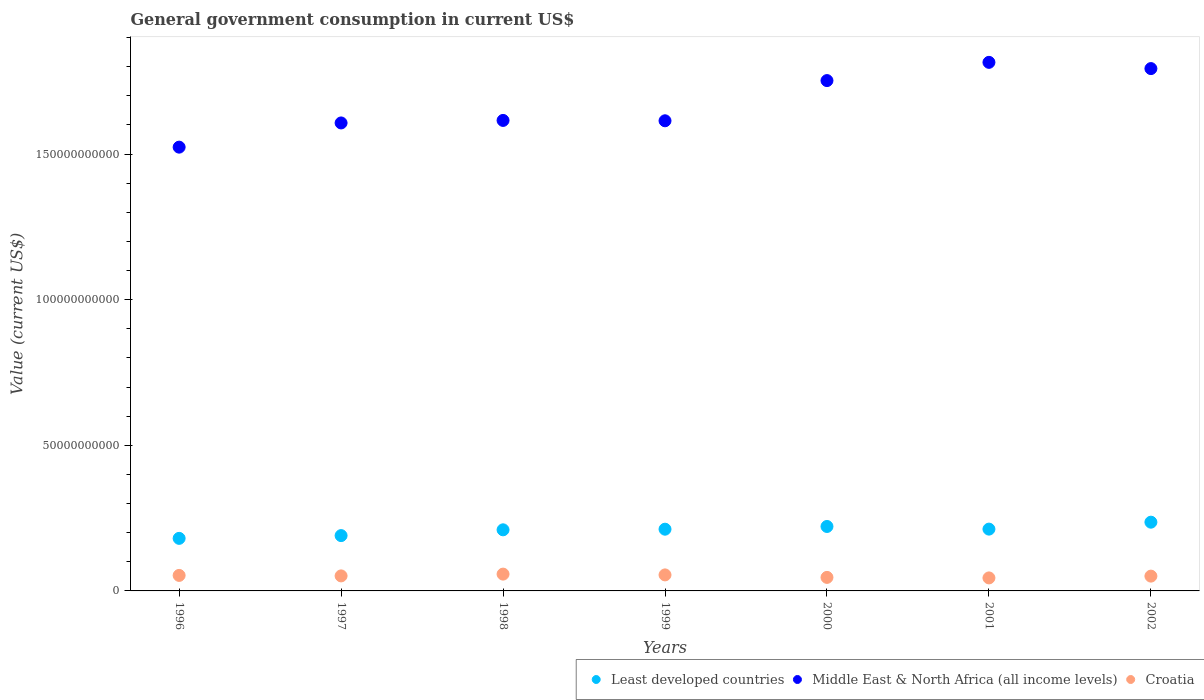How many different coloured dotlines are there?
Provide a short and direct response. 3. What is the government conusmption in Middle East & North Africa (all income levels) in 1998?
Your answer should be very brief. 1.62e+11. Across all years, what is the maximum government conusmption in Croatia?
Offer a very short reply. 5.77e+09. Across all years, what is the minimum government conusmption in Middle East & North Africa (all income levels)?
Keep it short and to the point. 1.52e+11. In which year was the government conusmption in Middle East & North Africa (all income levels) maximum?
Your response must be concise. 2001. In which year was the government conusmption in Least developed countries minimum?
Your answer should be compact. 1996. What is the total government conusmption in Middle East & North Africa (all income levels) in the graph?
Keep it short and to the point. 1.17e+12. What is the difference between the government conusmption in Croatia in 1999 and that in 2000?
Your answer should be compact. 8.54e+08. What is the difference between the government conusmption in Croatia in 1998 and the government conusmption in Middle East & North Africa (all income levels) in 1999?
Your answer should be very brief. -1.56e+11. What is the average government conusmption in Middle East & North Africa (all income levels) per year?
Offer a terse response. 1.67e+11. In the year 2000, what is the difference between the government conusmption in Croatia and government conusmption in Least developed countries?
Offer a terse response. -1.75e+1. What is the ratio of the government conusmption in Croatia in 1996 to that in 2001?
Give a very brief answer. 1.19. Is the government conusmption in Middle East & North Africa (all income levels) in 1998 less than that in 2000?
Offer a terse response. Yes. Is the difference between the government conusmption in Croatia in 1997 and 1998 greater than the difference between the government conusmption in Least developed countries in 1997 and 1998?
Keep it short and to the point. Yes. What is the difference between the highest and the second highest government conusmption in Croatia?
Your response must be concise. 2.72e+08. What is the difference between the highest and the lowest government conusmption in Least developed countries?
Provide a short and direct response. 5.56e+09. Is the sum of the government conusmption in Least developed countries in 1996 and 1997 greater than the maximum government conusmption in Croatia across all years?
Offer a terse response. Yes. Is the government conusmption in Middle East & North Africa (all income levels) strictly greater than the government conusmption in Least developed countries over the years?
Keep it short and to the point. Yes. How many dotlines are there?
Give a very brief answer. 3. Does the graph contain grids?
Keep it short and to the point. No. Where does the legend appear in the graph?
Your answer should be compact. Bottom right. How are the legend labels stacked?
Keep it short and to the point. Horizontal. What is the title of the graph?
Your answer should be compact. General government consumption in current US$. Does "Argentina" appear as one of the legend labels in the graph?
Your answer should be very brief. No. What is the label or title of the Y-axis?
Give a very brief answer. Value (current US$). What is the Value (current US$) of Least developed countries in 1996?
Provide a succinct answer. 1.80e+1. What is the Value (current US$) in Middle East & North Africa (all income levels) in 1996?
Keep it short and to the point. 1.52e+11. What is the Value (current US$) of Croatia in 1996?
Ensure brevity in your answer.  5.33e+09. What is the Value (current US$) of Least developed countries in 1997?
Make the answer very short. 1.90e+1. What is the Value (current US$) of Middle East & North Africa (all income levels) in 1997?
Ensure brevity in your answer.  1.61e+11. What is the Value (current US$) in Croatia in 1997?
Your answer should be compact. 5.16e+09. What is the Value (current US$) of Least developed countries in 1998?
Offer a terse response. 2.10e+1. What is the Value (current US$) of Middle East & North Africa (all income levels) in 1998?
Give a very brief answer. 1.62e+11. What is the Value (current US$) in Croatia in 1998?
Give a very brief answer. 5.77e+09. What is the Value (current US$) in Least developed countries in 1999?
Offer a very short reply. 2.12e+1. What is the Value (current US$) in Middle East & North Africa (all income levels) in 1999?
Make the answer very short. 1.61e+11. What is the Value (current US$) in Croatia in 1999?
Give a very brief answer. 5.50e+09. What is the Value (current US$) of Least developed countries in 2000?
Provide a succinct answer. 2.21e+1. What is the Value (current US$) in Middle East & North Africa (all income levels) in 2000?
Make the answer very short. 1.75e+11. What is the Value (current US$) in Croatia in 2000?
Offer a terse response. 4.65e+09. What is the Value (current US$) in Least developed countries in 2001?
Provide a short and direct response. 2.12e+1. What is the Value (current US$) of Middle East & North Africa (all income levels) in 2001?
Provide a short and direct response. 1.81e+11. What is the Value (current US$) of Croatia in 2001?
Make the answer very short. 4.47e+09. What is the Value (current US$) of Least developed countries in 2002?
Offer a terse response. 2.36e+1. What is the Value (current US$) of Middle East & North Africa (all income levels) in 2002?
Give a very brief answer. 1.79e+11. What is the Value (current US$) in Croatia in 2002?
Give a very brief answer. 5.08e+09. Across all years, what is the maximum Value (current US$) in Least developed countries?
Provide a short and direct response. 2.36e+1. Across all years, what is the maximum Value (current US$) of Middle East & North Africa (all income levels)?
Your answer should be compact. 1.81e+11. Across all years, what is the maximum Value (current US$) of Croatia?
Provide a succinct answer. 5.77e+09. Across all years, what is the minimum Value (current US$) in Least developed countries?
Provide a short and direct response. 1.80e+1. Across all years, what is the minimum Value (current US$) in Middle East & North Africa (all income levels)?
Provide a succinct answer. 1.52e+11. Across all years, what is the minimum Value (current US$) in Croatia?
Give a very brief answer. 4.47e+09. What is the total Value (current US$) of Least developed countries in the graph?
Your answer should be very brief. 1.46e+11. What is the total Value (current US$) in Middle East & North Africa (all income levels) in the graph?
Your answer should be very brief. 1.17e+12. What is the total Value (current US$) in Croatia in the graph?
Keep it short and to the point. 3.59e+1. What is the difference between the Value (current US$) of Least developed countries in 1996 and that in 1997?
Make the answer very short. -9.50e+08. What is the difference between the Value (current US$) of Middle East & North Africa (all income levels) in 1996 and that in 1997?
Your answer should be very brief. -8.31e+09. What is the difference between the Value (current US$) of Croatia in 1996 and that in 1997?
Give a very brief answer. 1.67e+08. What is the difference between the Value (current US$) of Least developed countries in 1996 and that in 1998?
Offer a terse response. -2.93e+09. What is the difference between the Value (current US$) in Middle East & North Africa (all income levels) in 1996 and that in 1998?
Your answer should be very brief. -9.18e+09. What is the difference between the Value (current US$) in Croatia in 1996 and that in 1998?
Your response must be concise. -4.45e+08. What is the difference between the Value (current US$) in Least developed countries in 1996 and that in 1999?
Your answer should be compact. -3.15e+09. What is the difference between the Value (current US$) in Middle East & North Africa (all income levels) in 1996 and that in 1999?
Offer a terse response. -9.05e+09. What is the difference between the Value (current US$) in Croatia in 1996 and that in 1999?
Make the answer very short. -1.73e+08. What is the difference between the Value (current US$) in Least developed countries in 1996 and that in 2000?
Provide a short and direct response. -4.08e+09. What is the difference between the Value (current US$) of Middle East & North Africa (all income levels) in 1996 and that in 2000?
Offer a terse response. -2.29e+1. What is the difference between the Value (current US$) in Croatia in 1996 and that in 2000?
Ensure brevity in your answer.  6.81e+08. What is the difference between the Value (current US$) of Least developed countries in 1996 and that in 2001?
Make the answer very short. -3.17e+09. What is the difference between the Value (current US$) of Middle East & North Africa (all income levels) in 1996 and that in 2001?
Give a very brief answer. -2.91e+1. What is the difference between the Value (current US$) of Croatia in 1996 and that in 2001?
Offer a terse response. 8.59e+08. What is the difference between the Value (current US$) of Least developed countries in 1996 and that in 2002?
Keep it short and to the point. -5.56e+09. What is the difference between the Value (current US$) in Middle East & North Africa (all income levels) in 1996 and that in 2002?
Offer a terse response. -2.70e+1. What is the difference between the Value (current US$) of Croatia in 1996 and that in 2002?
Make the answer very short. 2.45e+08. What is the difference between the Value (current US$) of Least developed countries in 1997 and that in 1998?
Provide a short and direct response. -1.98e+09. What is the difference between the Value (current US$) in Middle East & North Africa (all income levels) in 1997 and that in 1998?
Give a very brief answer. -8.66e+08. What is the difference between the Value (current US$) of Croatia in 1997 and that in 1998?
Give a very brief answer. -6.12e+08. What is the difference between the Value (current US$) of Least developed countries in 1997 and that in 1999?
Make the answer very short. -2.20e+09. What is the difference between the Value (current US$) in Middle East & North Africa (all income levels) in 1997 and that in 1999?
Your answer should be very brief. -7.43e+08. What is the difference between the Value (current US$) in Croatia in 1997 and that in 1999?
Offer a very short reply. -3.41e+08. What is the difference between the Value (current US$) of Least developed countries in 1997 and that in 2000?
Offer a terse response. -3.13e+09. What is the difference between the Value (current US$) in Middle East & North Africa (all income levels) in 1997 and that in 2000?
Ensure brevity in your answer.  -1.45e+1. What is the difference between the Value (current US$) of Croatia in 1997 and that in 2000?
Keep it short and to the point. 5.13e+08. What is the difference between the Value (current US$) of Least developed countries in 1997 and that in 2001?
Offer a terse response. -2.22e+09. What is the difference between the Value (current US$) in Middle East & North Africa (all income levels) in 1997 and that in 2001?
Ensure brevity in your answer.  -2.08e+1. What is the difference between the Value (current US$) in Croatia in 1997 and that in 2001?
Ensure brevity in your answer.  6.92e+08. What is the difference between the Value (current US$) of Least developed countries in 1997 and that in 2002?
Offer a very short reply. -4.61e+09. What is the difference between the Value (current US$) in Middle East & North Africa (all income levels) in 1997 and that in 2002?
Your answer should be very brief. -1.87e+1. What is the difference between the Value (current US$) of Croatia in 1997 and that in 2002?
Give a very brief answer. 7.82e+07. What is the difference between the Value (current US$) of Least developed countries in 1998 and that in 1999?
Make the answer very short. -2.15e+08. What is the difference between the Value (current US$) in Middle East & North Africa (all income levels) in 1998 and that in 1999?
Offer a very short reply. 1.24e+08. What is the difference between the Value (current US$) of Croatia in 1998 and that in 1999?
Your response must be concise. 2.72e+08. What is the difference between the Value (current US$) in Least developed countries in 1998 and that in 2000?
Keep it short and to the point. -1.15e+09. What is the difference between the Value (current US$) in Middle East & North Africa (all income levels) in 1998 and that in 2000?
Offer a terse response. -1.37e+1. What is the difference between the Value (current US$) in Croatia in 1998 and that in 2000?
Ensure brevity in your answer.  1.13e+09. What is the difference between the Value (current US$) of Least developed countries in 1998 and that in 2001?
Make the answer very short. -2.39e+08. What is the difference between the Value (current US$) of Middle East & North Africa (all income levels) in 1998 and that in 2001?
Your answer should be very brief. -1.99e+1. What is the difference between the Value (current US$) of Croatia in 1998 and that in 2001?
Give a very brief answer. 1.30e+09. What is the difference between the Value (current US$) of Least developed countries in 1998 and that in 2002?
Offer a terse response. -2.62e+09. What is the difference between the Value (current US$) in Middle East & North Africa (all income levels) in 1998 and that in 2002?
Your answer should be very brief. -1.78e+1. What is the difference between the Value (current US$) in Croatia in 1998 and that in 2002?
Give a very brief answer. 6.91e+08. What is the difference between the Value (current US$) of Least developed countries in 1999 and that in 2000?
Ensure brevity in your answer.  -9.33e+08. What is the difference between the Value (current US$) of Middle East & North Africa (all income levels) in 1999 and that in 2000?
Provide a short and direct response. -1.38e+1. What is the difference between the Value (current US$) of Croatia in 1999 and that in 2000?
Give a very brief answer. 8.54e+08. What is the difference between the Value (current US$) of Least developed countries in 1999 and that in 2001?
Provide a succinct answer. -2.41e+07. What is the difference between the Value (current US$) of Middle East & North Africa (all income levels) in 1999 and that in 2001?
Provide a succinct answer. -2.01e+1. What is the difference between the Value (current US$) in Croatia in 1999 and that in 2001?
Give a very brief answer. 1.03e+09. What is the difference between the Value (current US$) in Least developed countries in 1999 and that in 2002?
Provide a succinct answer. -2.41e+09. What is the difference between the Value (current US$) in Middle East & North Africa (all income levels) in 1999 and that in 2002?
Your response must be concise. -1.79e+1. What is the difference between the Value (current US$) of Croatia in 1999 and that in 2002?
Your answer should be very brief. 4.19e+08. What is the difference between the Value (current US$) in Least developed countries in 2000 and that in 2001?
Your answer should be very brief. 9.09e+08. What is the difference between the Value (current US$) in Middle East & North Africa (all income levels) in 2000 and that in 2001?
Keep it short and to the point. -6.26e+09. What is the difference between the Value (current US$) of Croatia in 2000 and that in 2001?
Give a very brief answer. 1.78e+08. What is the difference between the Value (current US$) in Least developed countries in 2000 and that in 2002?
Offer a terse response. -1.47e+09. What is the difference between the Value (current US$) in Middle East & North Africa (all income levels) in 2000 and that in 2002?
Provide a short and direct response. -4.12e+09. What is the difference between the Value (current US$) of Croatia in 2000 and that in 2002?
Keep it short and to the point. -4.35e+08. What is the difference between the Value (current US$) of Least developed countries in 2001 and that in 2002?
Provide a short and direct response. -2.38e+09. What is the difference between the Value (current US$) of Middle East & North Africa (all income levels) in 2001 and that in 2002?
Give a very brief answer. 2.14e+09. What is the difference between the Value (current US$) of Croatia in 2001 and that in 2002?
Ensure brevity in your answer.  -6.14e+08. What is the difference between the Value (current US$) of Least developed countries in 1996 and the Value (current US$) of Middle East & North Africa (all income levels) in 1997?
Your response must be concise. -1.43e+11. What is the difference between the Value (current US$) in Least developed countries in 1996 and the Value (current US$) in Croatia in 1997?
Your answer should be compact. 1.29e+1. What is the difference between the Value (current US$) of Middle East & North Africa (all income levels) in 1996 and the Value (current US$) of Croatia in 1997?
Your response must be concise. 1.47e+11. What is the difference between the Value (current US$) of Least developed countries in 1996 and the Value (current US$) of Middle East & North Africa (all income levels) in 1998?
Provide a short and direct response. -1.44e+11. What is the difference between the Value (current US$) of Least developed countries in 1996 and the Value (current US$) of Croatia in 1998?
Your answer should be compact. 1.23e+1. What is the difference between the Value (current US$) in Middle East & North Africa (all income levels) in 1996 and the Value (current US$) in Croatia in 1998?
Offer a terse response. 1.47e+11. What is the difference between the Value (current US$) in Least developed countries in 1996 and the Value (current US$) in Middle East & North Africa (all income levels) in 1999?
Your response must be concise. -1.43e+11. What is the difference between the Value (current US$) of Least developed countries in 1996 and the Value (current US$) of Croatia in 1999?
Offer a terse response. 1.25e+1. What is the difference between the Value (current US$) in Middle East & North Africa (all income levels) in 1996 and the Value (current US$) in Croatia in 1999?
Give a very brief answer. 1.47e+11. What is the difference between the Value (current US$) in Least developed countries in 1996 and the Value (current US$) in Middle East & North Africa (all income levels) in 2000?
Your response must be concise. -1.57e+11. What is the difference between the Value (current US$) in Least developed countries in 1996 and the Value (current US$) in Croatia in 2000?
Give a very brief answer. 1.34e+1. What is the difference between the Value (current US$) in Middle East & North Africa (all income levels) in 1996 and the Value (current US$) in Croatia in 2000?
Your answer should be compact. 1.48e+11. What is the difference between the Value (current US$) in Least developed countries in 1996 and the Value (current US$) in Middle East & North Africa (all income levels) in 2001?
Keep it short and to the point. -1.63e+11. What is the difference between the Value (current US$) in Least developed countries in 1996 and the Value (current US$) in Croatia in 2001?
Provide a short and direct response. 1.36e+1. What is the difference between the Value (current US$) of Middle East & North Africa (all income levels) in 1996 and the Value (current US$) of Croatia in 2001?
Provide a short and direct response. 1.48e+11. What is the difference between the Value (current US$) of Least developed countries in 1996 and the Value (current US$) of Middle East & North Africa (all income levels) in 2002?
Offer a very short reply. -1.61e+11. What is the difference between the Value (current US$) of Least developed countries in 1996 and the Value (current US$) of Croatia in 2002?
Ensure brevity in your answer.  1.30e+1. What is the difference between the Value (current US$) in Middle East & North Africa (all income levels) in 1996 and the Value (current US$) in Croatia in 2002?
Keep it short and to the point. 1.47e+11. What is the difference between the Value (current US$) in Least developed countries in 1997 and the Value (current US$) in Middle East & North Africa (all income levels) in 1998?
Ensure brevity in your answer.  -1.43e+11. What is the difference between the Value (current US$) in Least developed countries in 1997 and the Value (current US$) in Croatia in 1998?
Offer a very short reply. 1.32e+1. What is the difference between the Value (current US$) of Middle East & North Africa (all income levels) in 1997 and the Value (current US$) of Croatia in 1998?
Provide a succinct answer. 1.55e+11. What is the difference between the Value (current US$) of Least developed countries in 1997 and the Value (current US$) of Middle East & North Africa (all income levels) in 1999?
Provide a short and direct response. -1.42e+11. What is the difference between the Value (current US$) in Least developed countries in 1997 and the Value (current US$) in Croatia in 1999?
Your answer should be compact. 1.35e+1. What is the difference between the Value (current US$) of Middle East & North Africa (all income levels) in 1997 and the Value (current US$) of Croatia in 1999?
Your response must be concise. 1.55e+11. What is the difference between the Value (current US$) in Least developed countries in 1997 and the Value (current US$) in Middle East & North Africa (all income levels) in 2000?
Your answer should be very brief. -1.56e+11. What is the difference between the Value (current US$) of Least developed countries in 1997 and the Value (current US$) of Croatia in 2000?
Your answer should be compact. 1.44e+1. What is the difference between the Value (current US$) in Middle East & North Africa (all income levels) in 1997 and the Value (current US$) in Croatia in 2000?
Offer a very short reply. 1.56e+11. What is the difference between the Value (current US$) of Least developed countries in 1997 and the Value (current US$) of Middle East & North Africa (all income levels) in 2001?
Make the answer very short. -1.63e+11. What is the difference between the Value (current US$) of Least developed countries in 1997 and the Value (current US$) of Croatia in 2001?
Give a very brief answer. 1.45e+1. What is the difference between the Value (current US$) of Middle East & North Africa (all income levels) in 1997 and the Value (current US$) of Croatia in 2001?
Keep it short and to the point. 1.56e+11. What is the difference between the Value (current US$) of Least developed countries in 1997 and the Value (current US$) of Middle East & North Africa (all income levels) in 2002?
Your answer should be compact. -1.60e+11. What is the difference between the Value (current US$) of Least developed countries in 1997 and the Value (current US$) of Croatia in 2002?
Keep it short and to the point. 1.39e+1. What is the difference between the Value (current US$) of Middle East & North Africa (all income levels) in 1997 and the Value (current US$) of Croatia in 2002?
Your answer should be compact. 1.56e+11. What is the difference between the Value (current US$) of Least developed countries in 1998 and the Value (current US$) of Middle East & North Africa (all income levels) in 1999?
Give a very brief answer. -1.40e+11. What is the difference between the Value (current US$) of Least developed countries in 1998 and the Value (current US$) of Croatia in 1999?
Offer a very short reply. 1.55e+1. What is the difference between the Value (current US$) in Middle East & North Africa (all income levels) in 1998 and the Value (current US$) in Croatia in 1999?
Your answer should be compact. 1.56e+11. What is the difference between the Value (current US$) in Least developed countries in 1998 and the Value (current US$) in Middle East & North Africa (all income levels) in 2000?
Make the answer very short. -1.54e+11. What is the difference between the Value (current US$) in Least developed countries in 1998 and the Value (current US$) in Croatia in 2000?
Make the answer very short. 1.63e+1. What is the difference between the Value (current US$) in Middle East & North Africa (all income levels) in 1998 and the Value (current US$) in Croatia in 2000?
Your answer should be compact. 1.57e+11. What is the difference between the Value (current US$) of Least developed countries in 1998 and the Value (current US$) of Middle East & North Africa (all income levels) in 2001?
Make the answer very short. -1.61e+11. What is the difference between the Value (current US$) in Least developed countries in 1998 and the Value (current US$) in Croatia in 2001?
Give a very brief answer. 1.65e+1. What is the difference between the Value (current US$) in Middle East & North Africa (all income levels) in 1998 and the Value (current US$) in Croatia in 2001?
Your response must be concise. 1.57e+11. What is the difference between the Value (current US$) in Least developed countries in 1998 and the Value (current US$) in Middle East & North Africa (all income levels) in 2002?
Offer a terse response. -1.58e+11. What is the difference between the Value (current US$) in Least developed countries in 1998 and the Value (current US$) in Croatia in 2002?
Provide a short and direct response. 1.59e+1. What is the difference between the Value (current US$) of Middle East & North Africa (all income levels) in 1998 and the Value (current US$) of Croatia in 2002?
Give a very brief answer. 1.56e+11. What is the difference between the Value (current US$) of Least developed countries in 1999 and the Value (current US$) of Middle East & North Africa (all income levels) in 2000?
Your answer should be very brief. -1.54e+11. What is the difference between the Value (current US$) of Least developed countries in 1999 and the Value (current US$) of Croatia in 2000?
Provide a succinct answer. 1.66e+1. What is the difference between the Value (current US$) in Middle East & North Africa (all income levels) in 1999 and the Value (current US$) in Croatia in 2000?
Provide a succinct answer. 1.57e+11. What is the difference between the Value (current US$) in Least developed countries in 1999 and the Value (current US$) in Middle East & North Africa (all income levels) in 2001?
Provide a succinct answer. -1.60e+11. What is the difference between the Value (current US$) of Least developed countries in 1999 and the Value (current US$) of Croatia in 2001?
Offer a very short reply. 1.67e+1. What is the difference between the Value (current US$) in Middle East & North Africa (all income levels) in 1999 and the Value (current US$) in Croatia in 2001?
Keep it short and to the point. 1.57e+11. What is the difference between the Value (current US$) of Least developed countries in 1999 and the Value (current US$) of Middle East & North Africa (all income levels) in 2002?
Your answer should be very brief. -1.58e+11. What is the difference between the Value (current US$) in Least developed countries in 1999 and the Value (current US$) in Croatia in 2002?
Offer a very short reply. 1.61e+1. What is the difference between the Value (current US$) of Middle East & North Africa (all income levels) in 1999 and the Value (current US$) of Croatia in 2002?
Your answer should be compact. 1.56e+11. What is the difference between the Value (current US$) in Least developed countries in 2000 and the Value (current US$) in Middle East & North Africa (all income levels) in 2001?
Keep it short and to the point. -1.59e+11. What is the difference between the Value (current US$) of Least developed countries in 2000 and the Value (current US$) of Croatia in 2001?
Provide a short and direct response. 1.77e+1. What is the difference between the Value (current US$) in Middle East & North Africa (all income levels) in 2000 and the Value (current US$) in Croatia in 2001?
Keep it short and to the point. 1.71e+11. What is the difference between the Value (current US$) of Least developed countries in 2000 and the Value (current US$) of Middle East & North Africa (all income levels) in 2002?
Your answer should be compact. -1.57e+11. What is the difference between the Value (current US$) in Least developed countries in 2000 and the Value (current US$) in Croatia in 2002?
Offer a terse response. 1.70e+1. What is the difference between the Value (current US$) in Middle East & North Africa (all income levels) in 2000 and the Value (current US$) in Croatia in 2002?
Ensure brevity in your answer.  1.70e+11. What is the difference between the Value (current US$) of Least developed countries in 2001 and the Value (current US$) of Middle East & North Africa (all income levels) in 2002?
Offer a terse response. -1.58e+11. What is the difference between the Value (current US$) of Least developed countries in 2001 and the Value (current US$) of Croatia in 2002?
Offer a terse response. 1.61e+1. What is the difference between the Value (current US$) in Middle East & North Africa (all income levels) in 2001 and the Value (current US$) in Croatia in 2002?
Make the answer very short. 1.76e+11. What is the average Value (current US$) in Least developed countries per year?
Offer a terse response. 2.09e+1. What is the average Value (current US$) of Middle East & North Africa (all income levels) per year?
Your answer should be compact. 1.67e+11. What is the average Value (current US$) in Croatia per year?
Your answer should be compact. 5.14e+09. In the year 1996, what is the difference between the Value (current US$) of Least developed countries and Value (current US$) of Middle East & North Africa (all income levels)?
Make the answer very short. -1.34e+11. In the year 1996, what is the difference between the Value (current US$) in Least developed countries and Value (current US$) in Croatia?
Ensure brevity in your answer.  1.27e+1. In the year 1996, what is the difference between the Value (current US$) in Middle East & North Africa (all income levels) and Value (current US$) in Croatia?
Your answer should be very brief. 1.47e+11. In the year 1997, what is the difference between the Value (current US$) of Least developed countries and Value (current US$) of Middle East & North Africa (all income levels)?
Your answer should be very brief. -1.42e+11. In the year 1997, what is the difference between the Value (current US$) in Least developed countries and Value (current US$) in Croatia?
Give a very brief answer. 1.38e+1. In the year 1997, what is the difference between the Value (current US$) in Middle East & North Africa (all income levels) and Value (current US$) in Croatia?
Keep it short and to the point. 1.56e+11. In the year 1998, what is the difference between the Value (current US$) in Least developed countries and Value (current US$) in Middle East & North Africa (all income levels)?
Offer a very short reply. -1.41e+11. In the year 1998, what is the difference between the Value (current US$) of Least developed countries and Value (current US$) of Croatia?
Your response must be concise. 1.52e+1. In the year 1998, what is the difference between the Value (current US$) in Middle East & North Africa (all income levels) and Value (current US$) in Croatia?
Provide a short and direct response. 1.56e+11. In the year 1999, what is the difference between the Value (current US$) in Least developed countries and Value (current US$) in Middle East & North Africa (all income levels)?
Your answer should be compact. -1.40e+11. In the year 1999, what is the difference between the Value (current US$) of Least developed countries and Value (current US$) of Croatia?
Offer a terse response. 1.57e+1. In the year 1999, what is the difference between the Value (current US$) of Middle East & North Africa (all income levels) and Value (current US$) of Croatia?
Your answer should be very brief. 1.56e+11. In the year 2000, what is the difference between the Value (current US$) of Least developed countries and Value (current US$) of Middle East & North Africa (all income levels)?
Make the answer very short. -1.53e+11. In the year 2000, what is the difference between the Value (current US$) in Least developed countries and Value (current US$) in Croatia?
Your answer should be compact. 1.75e+1. In the year 2000, what is the difference between the Value (current US$) in Middle East & North Africa (all income levels) and Value (current US$) in Croatia?
Offer a terse response. 1.71e+11. In the year 2001, what is the difference between the Value (current US$) of Least developed countries and Value (current US$) of Middle East & North Africa (all income levels)?
Offer a terse response. -1.60e+11. In the year 2001, what is the difference between the Value (current US$) of Least developed countries and Value (current US$) of Croatia?
Ensure brevity in your answer.  1.68e+1. In the year 2001, what is the difference between the Value (current US$) of Middle East & North Africa (all income levels) and Value (current US$) of Croatia?
Keep it short and to the point. 1.77e+11. In the year 2002, what is the difference between the Value (current US$) of Least developed countries and Value (current US$) of Middle East & North Africa (all income levels)?
Offer a terse response. -1.56e+11. In the year 2002, what is the difference between the Value (current US$) of Least developed countries and Value (current US$) of Croatia?
Your response must be concise. 1.85e+1. In the year 2002, what is the difference between the Value (current US$) in Middle East & North Africa (all income levels) and Value (current US$) in Croatia?
Offer a very short reply. 1.74e+11. What is the ratio of the Value (current US$) of Least developed countries in 1996 to that in 1997?
Ensure brevity in your answer.  0.95. What is the ratio of the Value (current US$) of Middle East & North Africa (all income levels) in 1996 to that in 1997?
Your answer should be very brief. 0.95. What is the ratio of the Value (current US$) of Croatia in 1996 to that in 1997?
Provide a short and direct response. 1.03. What is the ratio of the Value (current US$) of Least developed countries in 1996 to that in 1998?
Make the answer very short. 0.86. What is the ratio of the Value (current US$) of Middle East & North Africa (all income levels) in 1996 to that in 1998?
Provide a short and direct response. 0.94. What is the ratio of the Value (current US$) of Croatia in 1996 to that in 1998?
Provide a succinct answer. 0.92. What is the ratio of the Value (current US$) of Least developed countries in 1996 to that in 1999?
Provide a short and direct response. 0.85. What is the ratio of the Value (current US$) in Middle East & North Africa (all income levels) in 1996 to that in 1999?
Your answer should be very brief. 0.94. What is the ratio of the Value (current US$) of Croatia in 1996 to that in 1999?
Your answer should be very brief. 0.97. What is the ratio of the Value (current US$) of Least developed countries in 1996 to that in 2000?
Ensure brevity in your answer.  0.82. What is the ratio of the Value (current US$) of Middle East & North Africa (all income levels) in 1996 to that in 2000?
Offer a very short reply. 0.87. What is the ratio of the Value (current US$) in Croatia in 1996 to that in 2000?
Keep it short and to the point. 1.15. What is the ratio of the Value (current US$) in Least developed countries in 1996 to that in 2001?
Offer a terse response. 0.85. What is the ratio of the Value (current US$) of Middle East & North Africa (all income levels) in 1996 to that in 2001?
Give a very brief answer. 0.84. What is the ratio of the Value (current US$) of Croatia in 1996 to that in 2001?
Provide a succinct answer. 1.19. What is the ratio of the Value (current US$) of Least developed countries in 1996 to that in 2002?
Offer a terse response. 0.76. What is the ratio of the Value (current US$) of Middle East & North Africa (all income levels) in 1996 to that in 2002?
Keep it short and to the point. 0.85. What is the ratio of the Value (current US$) in Croatia in 1996 to that in 2002?
Offer a terse response. 1.05. What is the ratio of the Value (current US$) in Least developed countries in 1997 to that in 1998?
Your answer should be very brief. 0.91. What is the ratio of the Value (current US$) of Middle East & North Africa (all income levels) in 1997 to that in 1998?
Your answer should be compact. 0.99. What is the ratio of the Value (current US$) of Croatia in 1997 to that in 1998?
Make the answer very short. 0.89. What is the ratio of the Value (current US$) of Least developed countries in 1997 to that in 1999?
Keep it short and to the point. 0.9. What is the ratio of the Value (current US$) of Croatia in 1997 to that in 1999?
Provide a short and direct response. 0.94. What is the ratio of the Value (current US$) of Least developed countries in 1997 to that in 2000?
Keep it short and to the point. 0.86. What is the ratio of the Value (current US$) of Middle East & North Africa (all income levels) in 1997 to that in 2000?
Provide a succinct answer. 0.92. What is the ratio of the Value (current US$) of Croatia in 1997 to that in 2000?
Make the answer very short. 1.11. What is the ratio of the Value (current US$) of Least developed countries in 1997 to that in 2001?
Give a very brief answer. 0.9. What is the ratio of the Value (current US$) in Middle East & North Africa (all income levels) in 1997 to that in 2001?
Make the answer very short. 0.89. What is the ratio of the Value (current US$) of Croatia in 1997 to that in 2001?
Give a very brief answer. 1.15. What is the ratio of the Value (current US$) in Least developed countries in 1997 to that in 2002?
Ensure brevity in your answer.  0.8. What is the ratio of the Value (current US$) of Middle East & North Africa (all income levels) in 1997 to that in 2002?
Your answer should be very brief. 0.9. What is the ratio of the Value (current US$) of Croatia in 1997 to that in 2002?
Your answer should be compact. 1.02. What is the ratio of the Value (current US$) in Middle East & North Africa (all income levels) in 1998 to that in 1999?
Make the answer very short. 1. What is the ratio of the Value (current US$) in Croatia in 1998 to that in 1999?
Keep it short and to the point. 1.05. What is the ratio of the Value (current US$) in Least developed countries in 1998 to that in 2000?
Your answer should be very brief. 0.95. What is the ratio of the Value (current US$) of Middle East & North Africa (all income levels) in 1998 to that in 2000?
Provide a short and direct response. 0.92. What is the ratio of the Value (current US$) of Croatia in 1998 to that in 2000?
Your answer should be very brief. 1.24. What is the ratio of the Value (current US$) in Least developed countries in 1998 to that in 2001?
Your answer should be compact. 0.99. What is the ratio of the Value (current US$) of Middle East & North Africa (all income levels) in 1998 to that in 2001?
Keep it short and to the point. 0.89. What is the ratio of the Value (current US$) in Croatia in 1998 to that in 2001?
Give a very brief answer. 1.29. What is the ratio of the Value (current US$) in Middle East & North Africa (all income levels) in 1998 to that in 2002?
Your response must be concise. 0.9. What is the ratio of the Value (current US$) in Croatia in 1998 to that in 2002?
Your response must be concise. 1.14. What is the ratio of the Value (current US$) in Least developed countries in 1999 to that in 2000?
Offer a terse response. 0.96. What is the ratio of the Value (current US$) of Middle East & North Africa (all income levels) in 1999 to that in 2000?
Give a very brief answer. 0.92. What is the ratio of the Value (current US$) of Croatia in 1999 to that in 2000?
Your response must be concise. 1.18. What is the ratio of the Value (current US$) of Least developed countries in 1999 to that in 2001?
Your response must be concise. 1. What is the ratio of the Value (current US$) in Middle East & North Africa (all income levels) in 1999 to that in 2001?
Provide a succinct answer. 0.89. What is the ratio of the Value (current US$) of Croatia in 1999 to that in 2001?
Provide a succinct answer. 1.23. What is the ratio of the Value (current US$) in Least developed countries in 1999 to that in 2002?
Provide a short and direct response. 0.9. What is the ratio of the Value (current US$) in Middle East & North Africa (all income levels) in 1999 to that in 2002?
Provide a short and direct response. 0.9. What is the ratio of the Value (current US$) in Croatia in 1999 to that in 2002?
Your answer should be very brief. 1.08. What is the ratio of the Value (current US$) of Least developed countries in 2000 to that in 2001?
Provide a succinct answer. 1.04. What is the ratio of the Value (current US$) in Middle East & North Africa (all income levels) in 2000 to that in 2001?
Provide a short and direct response. 0.97. What is the ratio of the Value (current US$) of Croatia in 2000 to that in 2001?
Your response must be concise. 1.04. What is the ratio of the Value (current US$) in Least developed countries in 2000 to that in 2002?
Keep it short and to the point. 0.94. What is the ratio of the Value (current US$) of Middle East & North Africa (all income levels) in 2000 to that in 2002?
Your answer should be very brief. 0.98. What is the ratio of the Value (current US$) in Croatia in 2000 to that in 2002?
Ensure brevity in your answer.  0.91. What is the ratio of the Value (current US$) of Least developed countries in 2001 to that in 2002?
Give a very brief answer. 0.9. What is the ratio of the Value (current US$) in Middle East & North Africa (all income levels) in 2001 to that in 2002?
Provide a succinct answer. 1.01. What is the ratio of the Value (current US$) of Croatia in 2001 to that in 2002?
Your answer should be compact. 0.88. What is the difference between the highest and the second highest Value (current US$) in Least developed countries?
Your answer should be very brief. 1.47e+09. What is the difference between the highest and the second highest Value (current US$) in Middle East & North Africa (all income levels)?
Give a very brief answer. 2.14e+09. What is the difference between the highest and the second highest Value (current US$) in Croatia?
Your answer should be compact. 2.72e+08. What is the difference between the highest and the lowest Value (current US$) in Least developed countries?
Ensure brevity in your answer.  5.56e+09. What is the difference between the highest and the lowest Value (current US$) of Middle East & North Africa (all income levels)?
Ensure brevity in your answer.  2.91e+1. What is the difference between the highest and the lowest Value (current US$) in Croatia?
Your answer should be compact. 1.30e+09. 